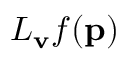Convert formula to latex. <formula><loc_0><loc_0><loc_500><loc_500>L _ { v } f ( p )</formula> 